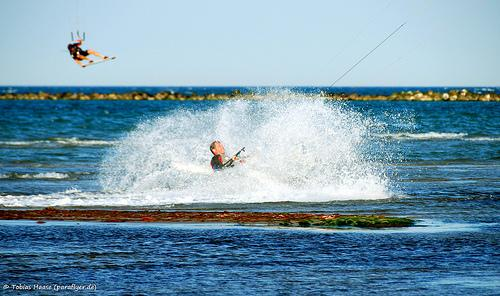What kind of suit is the surfer wearing and how is he attached to the rope? The surfer is wearing a black and red wetsuit and is attached to the rope with three strings. Provide a brief description of the scene in the image, including information about the man, water, and sky. A man wearing a wetsuit is performing a stunt over dark blue ocean water, while holding onto a rope. There is a light blue summer sky overhead with dim white clouds. How would you describe the overall sentiment or atmosphere of the image? The image has an adventurous and exhilarating atmosphere, with the man performing a stunt in the ocean. What is one unique action or feature of the man in the image? The man is hanging with both hands on a gray string. What color is the ocean and what is one object that is on it? The ocean is blue with a floating moat on the water. What is happening on the land or the coast? There is a rocky coast in front of the open ocean with a line of stones in the center of the ocean. What can you observe about the water in terms of movement or presence of waves? There is a large splash of water, small white cap waves, and the waves are moving. What is the color of the sky and what is happening in it? The sky is blue with dim white clouds and a man is parasailing in the background. Describe the state of the man and his position in the image. The man is wet, in the air, and positioned above the water. List two additional objects or observations in the image related to the main subject. A surfboard under the man and a hand hoisting a body up. Observe how the vibrant orange sunset creates a stunning contrast with the dark blue ocean water. There is no mention of a vibrant orange sunset in the list of objects present in the image. This would lead the viewer to search for a detail that isn't present. Could you please spot the pink elephant just by the rock wall on the left side of the image? There is no mention of a pink elephant in the list of objects present in the image. This would lead the viewer to look for something that doesn't exist. In the lower-left corner, do you see a group of red and white striped beach umbrellas on the small spot of land? There is no mention of red and white striped beach umbrellas in the list of objects present in the image. This instruction would mislead the viewer into looking for non-existent objects. Take a look at the family of seagulls flying in formation just above the light blue summer sky. There is no mention of seagulls in the list of objects present in the image. This would lead the viewer to search for non-existent birds. Can you spot the mermaid gracefully swimming alongside the surfer wearing a black suit? There is no mention of a mermaid in the list of objects present in the image. This instruction would mislead the viewer into looking for a fantastical creature that isn't there. Notice how the bright yellow submarine is partially submerged near the line of stones in the center of the ocean. There is no mention of a bright yellow submarine in the list of objects present in the image. This would lead the viewer to search for an object that isn't there. 